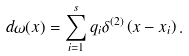<formula> <loc_0><loc_0><loc_500><loc_500>d \omega ( x ) = \sum _ { i = 1 } ^ { s } q _ { i } \delta ^ { ( 2 ) } \left ( x - x _ { i } \right ) .</formula> 